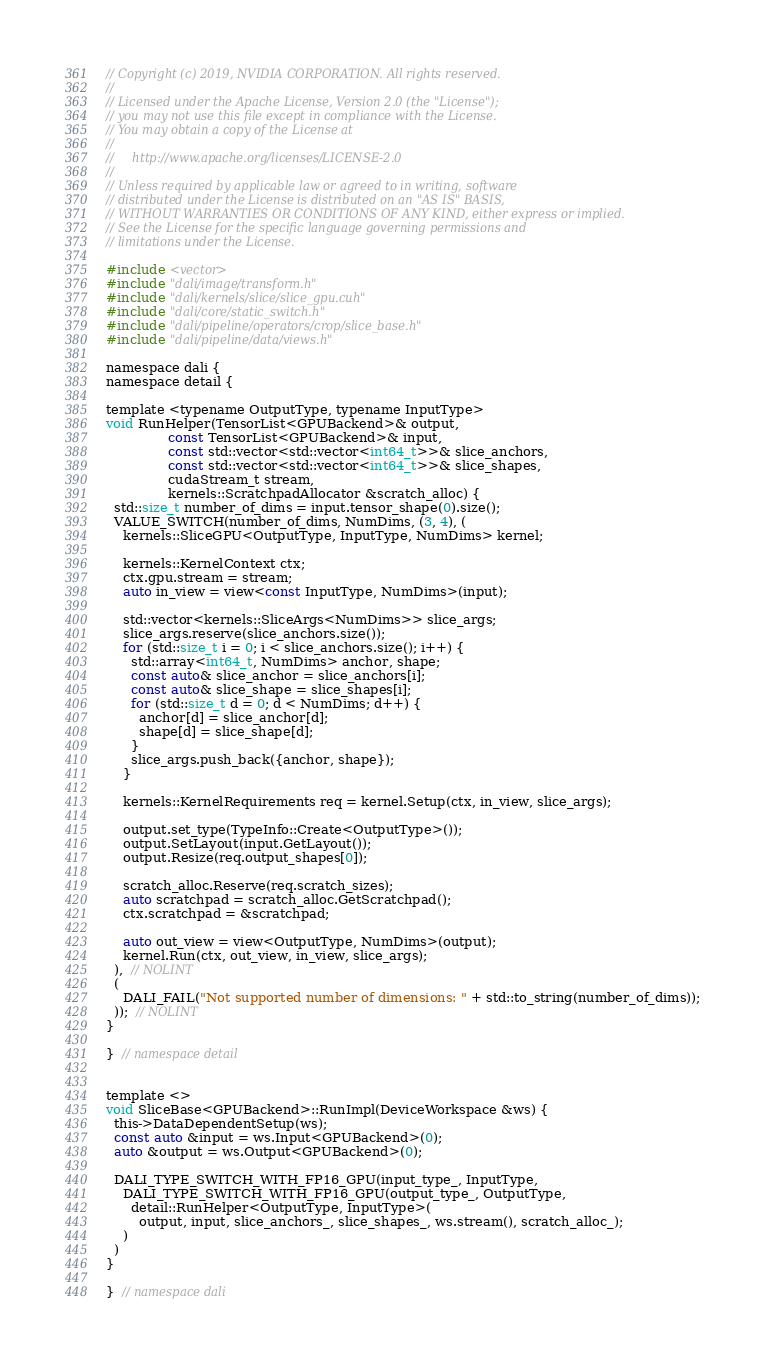Convert code to text. <code><loc_0><loc_0><loc_500><loc_500><_Cuda_>// Copyright (c) 2019, NVIDIA CORPORATION. All rights reserved.
//
// Licensed under the Apache License, Version 2.0 (the "License");
// you may not use this file except in compliance with the License.
// You may obtain a copy of the License at
//
//     http://www.apache.org/licenses/LICENSE-2.0
//
// Unless required by applicable law or agreed to in writing, software
// distributed under the License is distributed on an "AS IS" BASIS,
// WITHOUT WARRANTIES OR CONDITIONS OF ANY KIND, either express or implied.
// See the License for the specific language governing permissions and
// limitations under the License.

#include <vector>
#include "dali/image/transform.h"
#include "dali/kernels/slice/slice_gpu.cuh"
#include "dali/core/static_switch.h"
#include "dali/pipeline/operators/crop/slice_base.h"
#include "dali/pipeline/data/views.h"

namespace dali {
namespace detail {

template <typename OutputType, typename InputType>
void RunHelper(TensorList<GPUBackend>& output,
               const TensorList<GPUBackend>& input,
               const std::vector<std::vector<int64_t>>& slice_anchors,
               const std::vector<std::vector<int64_t>>& slice_shapes,
               cudaStream_t stream,
               kernels::ScratchpadAllocator &scratch_alloc) {
  std::size_t number_of_dims = input.tensor_shape(0).size();
  VALUE_SWITCH(number_of_dims, NumDims, (3, 4), (
    kernels::SliceGPU<OutputType, InputType, NumDims> kernel;

    kernels::KernelContext ctx;
    ctx.gpu.stream = stream;
    auto in_view = view<const InputType, NumDims>(input);

    std::vector<kernels::SliceArgs<NumDims>> slice_args;
    slice_args.reserve(slice_anchors.size());
    for (std::size_t i = 0; i < slice_anchors.size(); i++) {
      std::array<int64_t, NumDims> anchor, shape;
      const auto& slice_anchor = slice_anchors[i];
      const auto& slice_shape = slice_shapes[i];
      for (std::size_t d = 0; d < NumDims; d++) {
        anchor[d] = slice_anchor[d];
        shape[d] = slice_shape[d];
      }
      slice_args.push_back({anchor, shape});
    }

    kernels::KernelRequirements req = kernel.Setup(ctx, in_view, slice_args);

    output.set_type(TypeInfo::Create<OutputType>());
    output.SetLayout(input.GetLayout());
    output.Resize(req.output_shapes[0]);

    scratch_alloc.Reserve(req.scratch_sizes);
    auto scratchpad = scratch_alloc.GetScratchpad();
    ctx.scratchpad = &scratchpad;

    auto out_view = view<OutputType, NumDims>(output);
    kernel.Run(ctx, out_view, in_view, slice_args);
  ),  // NOLINT
  (
    DALI_FAIL("Not supported number of dimensions: " + std::to_string(number_of_dims));
  ));  // NOLINT
}

}  // namespace detail


template <>
void SliceBase<GPUBackend>::RunImpl(DeviceWorkspace &ws) {
  this->DataDependentSetup(ws);
  const auto &input = ws.Input<GPUBackend>(0);
  auto &output = ws.Output<GPUBackend>(0);

  DALI_TYPE_SWITCH_WITH_FP16_GPU(input_type_, InputType,
    DALI_TYPE_SWITCH_WITH_FP16_GPU(output_type_, OutputType,
      detail::RunHelper<OutputType, InputType>(
        output, input, slice_anchors_, slice_shapes_, ws.stream(), scratch_alloc_);
    )
  )
}

}  // namespace dali
</code> 